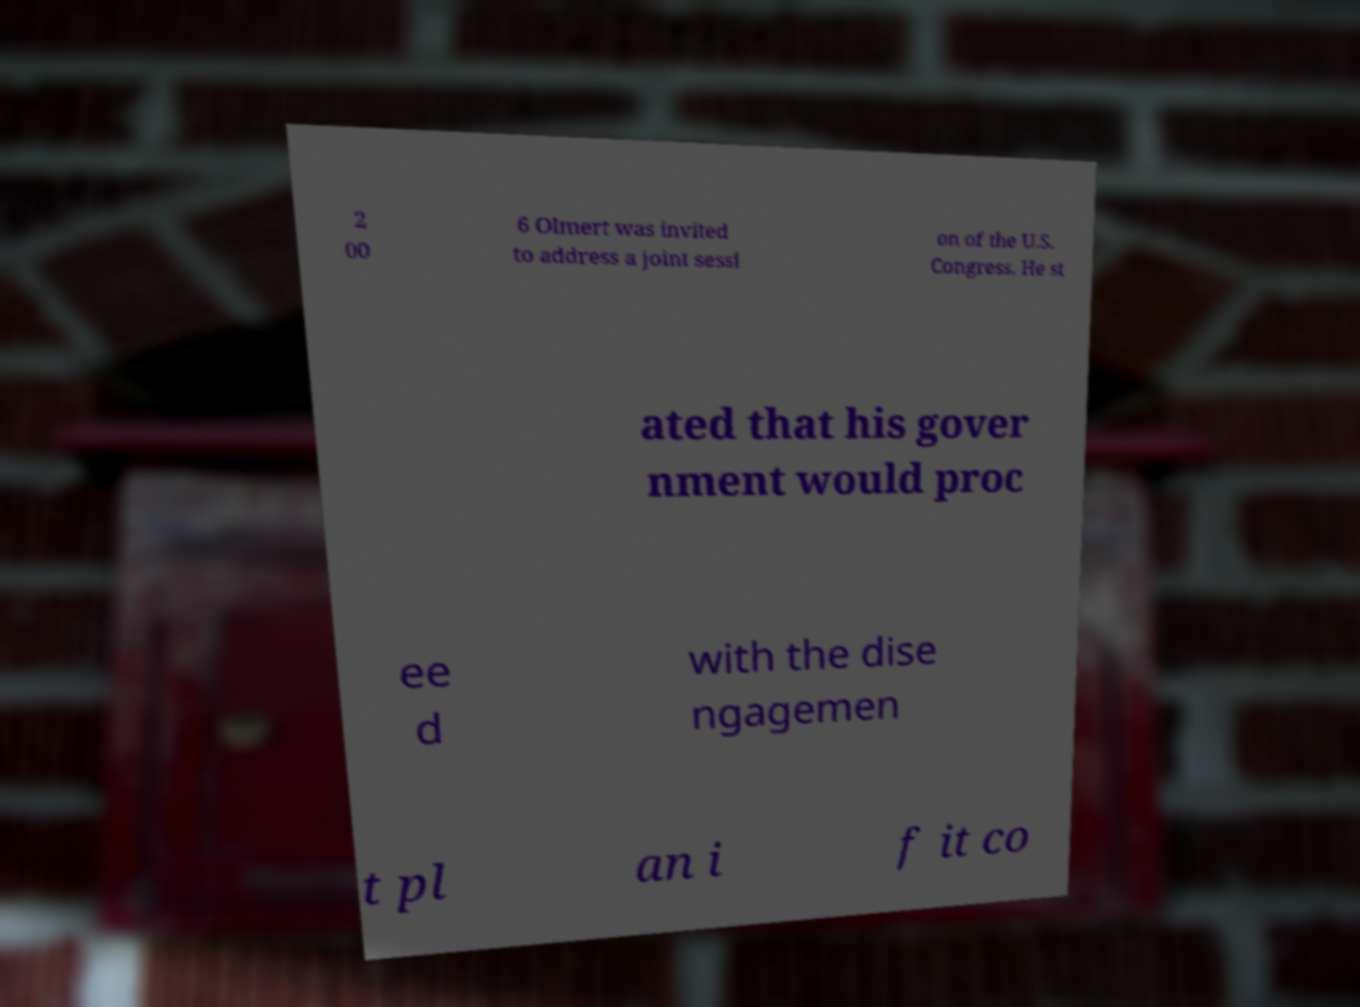I need the written content from this picture converted into text. Can you do that? 2 00 6 Olmert was invited to address a joint sessi on of the U.S. Congress. He st ated that his gover nment would proc ee d with the dise ngagemen t pl an i f it co 